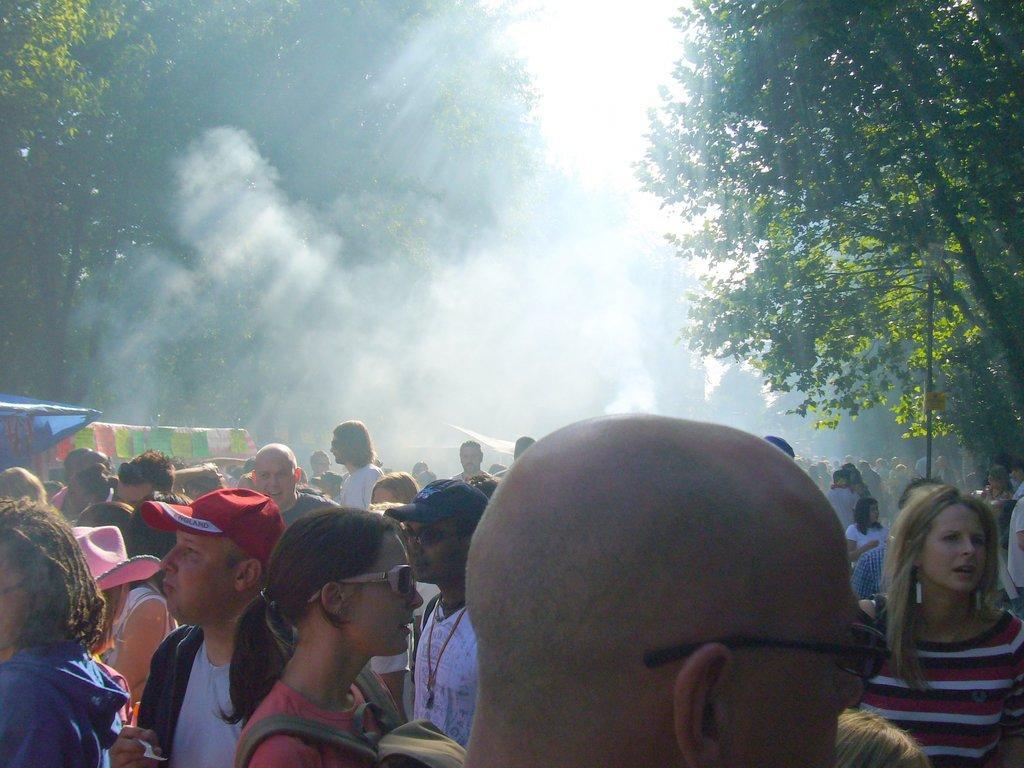Please provide a concise description of this image. In this image we can see some people standing and we can also see fig, trees and sky. 